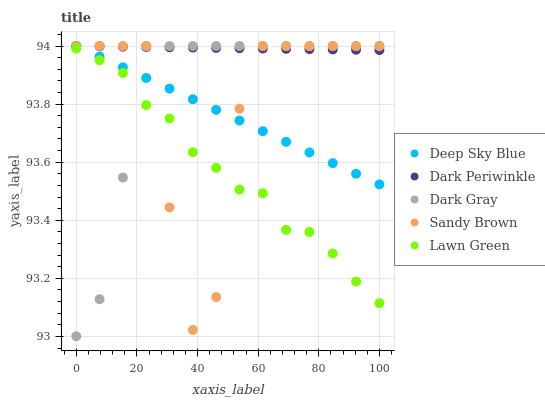Does Lawn Green have the minimum area under the curve?
Answer yes or no. Yes. Does Dark Periwinkle have the maximum area under the curve?
Answer yes or no. Yes. Does Sandy Brown have the minimum area under the curve?
Answer yes or no. No. Does Sandy Brown have the maximum area under the curve?
Answer yes or no. No. Is Dark Periwinkle the smoothest?
Answer yes or no. Yes. Is Sandy Brown the roughest?
Answer yes or no. Yes. Is Lawn Green the smoothest?
Answer yes or no. No. Is Lawn Green the roughest?
Answer yes or no. No. Does Dark Gray have the lowest value?
Answer yes or no. Yes. Does Lawn Green have the lowest value?
Answer yes or no. No. Does Deep Sky Blue have the highest value?
Answer yes or no. Yes. Does Lawn Green have the highest value?
Answer yes or no. No. Is Lawn Green less than Deep Sky Blue?
Answer yes or no. Yes. Is Dark Periwinkle greater than Lawn Green?
Answer yes or no. Yes. Does Lawn Green intersect Dark Gray?
Answer yes or no. Yes. Is Lawn Green less than Dark Gray?
Answer yes or no. No. Is Lawn Green greater than Dark Gray?
Answer yes or no. No. Does Lawn Green intersect Deep Sky Blue?
Answer yes or no. No. 